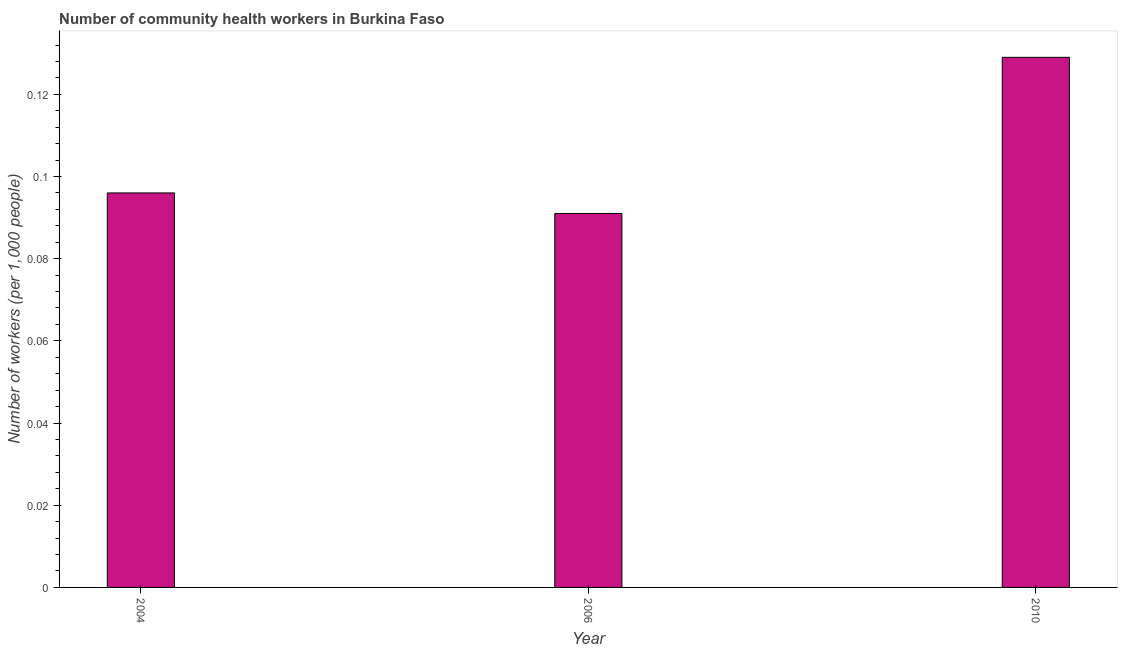What is the title of the graph?
Offer a very short reply. Number of community health workers in Burkina Faso. What is the label or title of the X-axis?
Provide a succinct answer. Year. What is the label or title of the Y-axis?
Offer a very short reply. Number of workers (per 1,0 people). What is the number of community health workers in 2004?
Your answer should be very brief. 0.1. Across all years, what is the maximum number of community health workers?
Your answer should be compact. 0.13. Across all years, what is the minimum number of community health workers?
Provide a short and direct response. 0.09. In which year was the number of community health workers minimum?
Your answer should be very brief. 2006. What is the sum of the number of community health workers?
Offer a terse response. 0.32. What is the difference between the number of community health workers in 2006 and 2010?
Offer a terse response. -0.04. What is the average number of community health workers per year?
Offer a very short reply. 0.1. What is the median number of community health workers?
Provide a short and direct response. 0.1. In how many years, is the number of community health workers greater than 0.036 ?
Offer a terse response. 3. Do a majority of the years between 2010 and 2004 (inclusive) have number of community health workers greater than 0.108 ?
Ensure brevity in your answer.  Yes. What is the ratio of the number of community health workers in 2004 to that in 2010?
Your answer should be very brief. 0.74. Is the number of community health workers in 2004 less than that in 2010?
Give a very brief answer. Yes. What is the difference between the highest and the second highest number of community health workers?
Ensure brevity in your answer.  0.03. What is the difference between the highest and the lowest number of community health workers?
Keep it short and to the point. 0.04. How many bars are there?
Keep it short and to the point. 3. Are all the bars in the graph horizontal?
Keep it short and to the point. No. How many years are there in the graph?
Your response must be concise. 3. What is the difference between two consecutive major ticks on the Y-axis?
Your response must be concise. 0.02. What is the Number of workers (per 1,000 people) in 2004?
Keep it short and to the point. 0.1. What is the Number of workers (per 1,000 people) of 2006?
Provide a succinct answer. 0.09. What is the Number of workers (per 1,000 people) in 2010?
Your answer should be compact. 0.13. What is the difference between the Number of workers (per 1,000 people) in 2004 and 2006?
Your answer should be compact. 0.01. What is the difference between the Number of workers (per 1,000 people) in 2004 and 2010?
Keep it short and to the point. -0.03. What is the difference between the Number of workers (per 1,000 people) in 2006 and 2010?
Your answer should be compact. -0.04. What is the ratio of the Number of workers (per 1,000 people) in 2004 to that in 2006?
Make the answer very short. 1.05. What is the ratio of the Number of workers (per 1,000 people) in 2004 to that in 2010?
Your response must be concise. 0.74. What is the ratio of the Number of workers (per 1,000 people) in 2006 to that in 2010?
Make the answer very short. 0.7. 